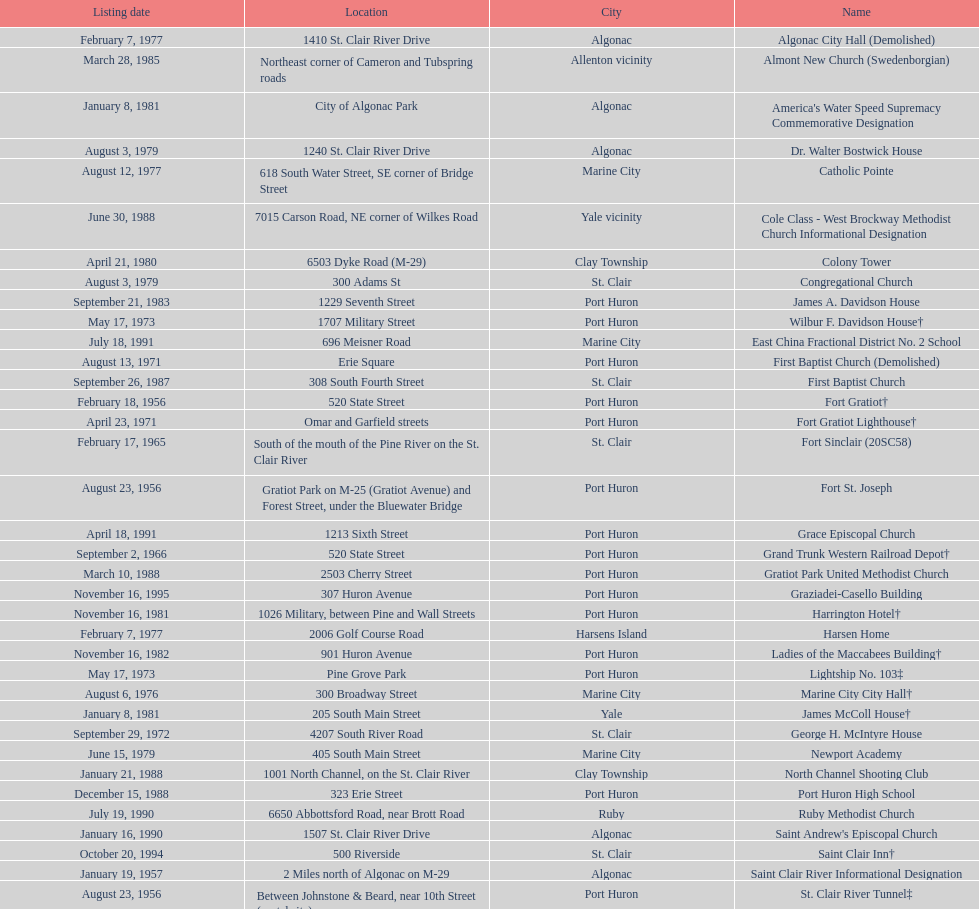What is the total number of locations in the city of algonac? 5. 